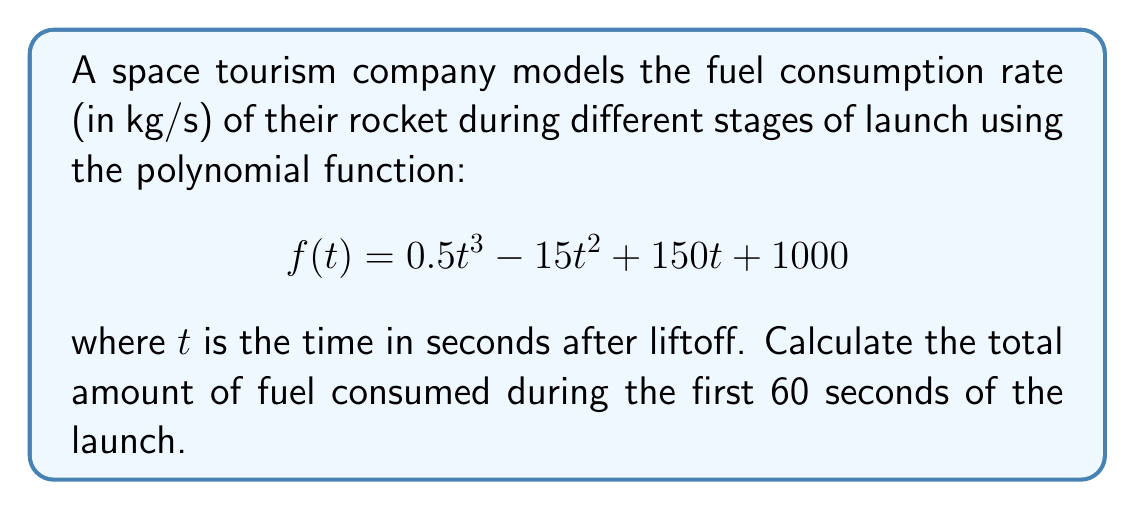Can you solve this math problem? To find the total amount of fuel consumed, we need to calculate the definite integral of the fuel consumption rate function from $t=0$ to $t=60$.

1. The integral of $f(t)$ is:
   $$F(t) = \int f(t) dt = \frac{1}{8}t^4 - 5t^3 + 75t^2 + 1000t + C$$

2. Calculate the definite integral:
   $$\text{Total fuel} = \int_0^{60} f(t) dt = F(60) - F(0)$$

3. Evaluate $F(60)$:
   $$F(60) = \frac{1}{8}(60^4) - 5(60^3) + 75(60^2) + 1000(60) = 810,000$$

4. Evaluate $F(0)$:
   $$F(0) = 0$$

5. Calculate the difference:
   $$\text{Total fuel} = F(60) - F(0) = 810,000 - 0 = 810,000 \text{ kg}$$

Therefore, the total amount of fuel consumed during the first 60 seconds of the launch is 810,000 kg.
Answer: 810,000 kg 